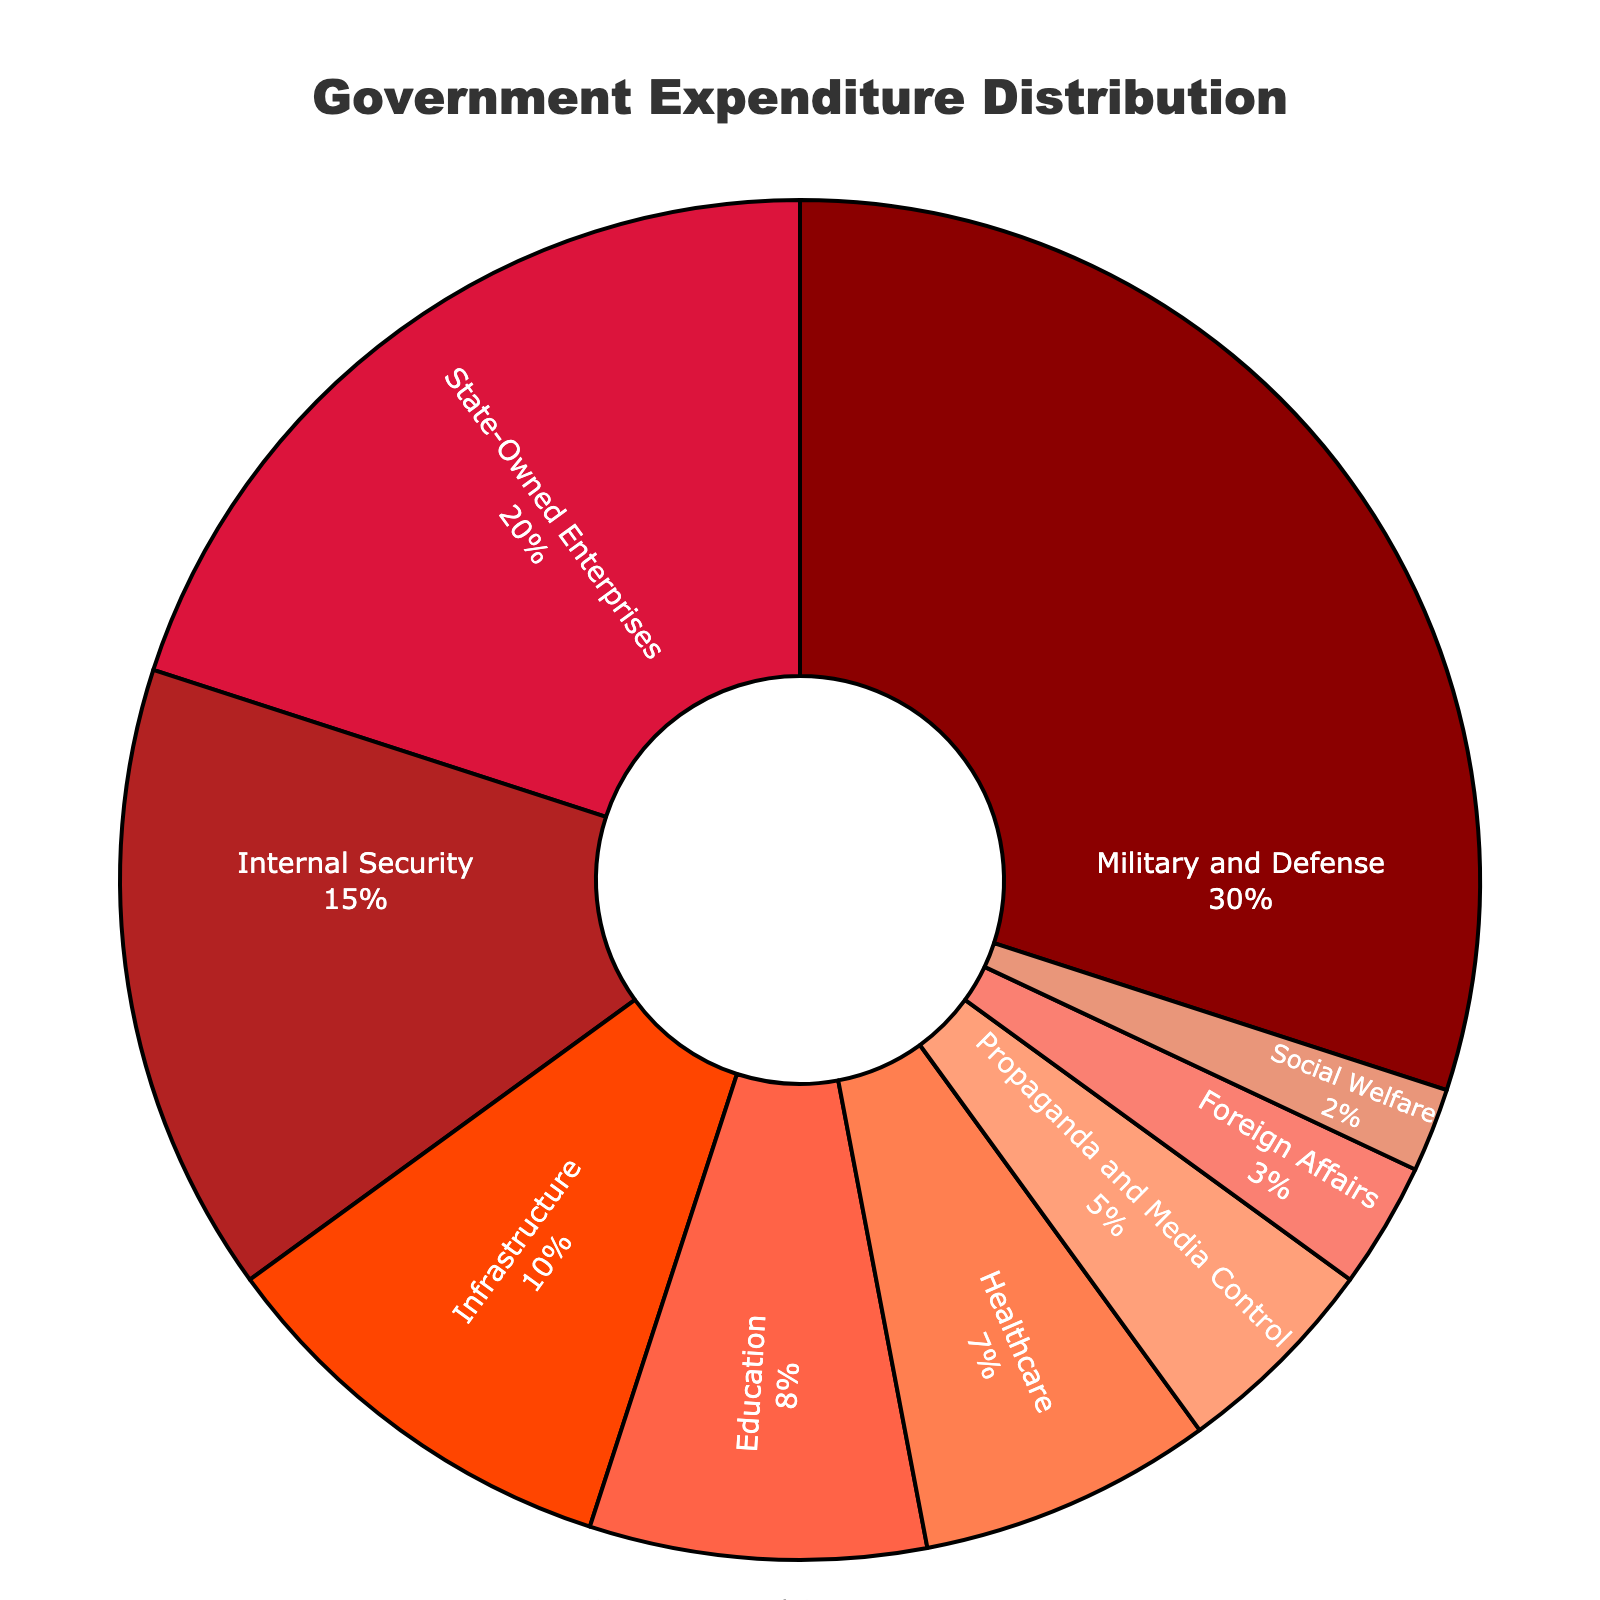What percentage of government expenditure is allocated to Military and Defense? According to the figure, the section labeled "Military and Defense" represents 30% of the government expenditure.
Answer: 30% What is the total percentage of government expenditure for Internal Security and Healthcare combined? The percentage for Internal Security is 15% and for Healthcare is 7%. Adding these together gives 15% + 7% = 22%.
Answer: 22% Which sector receives the smallest portion of government expenditure and what is that percentage? The figure shows that Social Welfare receives the smallest portion with 2%.
Answer: Social Welfare, 2% What sector is allocated twice the percentage of Foreign Affairs? Foreign Affairs is allocated 3%. Twice of 3% is 6%, which matches no exact sector. The closest higher sectors are Education (8%) and State-Owned Enterprises (20%).
Answer: None exactly; closest higher ones are Education (8%) and State-Owned Enterprises (20%) Are Military and Defense combined with Propaganda and Media Control higher or lower than the State-Owned Enterprises? Military and Defense accounts for 30%, and Propaganda and Media Control accounts for 5%, totaling 35%. State-Owned Enterprises account for 20%. Since 35% is greater than 20%, the combined amount is higher.
Answer: Higher How does the expenditure on Infrastructure compare to that on Education? Expenditure on Infrastructure is 10%, and on Education, it's 8%. Infrastructure expenditure is higher by 2%.
Answer: Infrastructure is higher What is the combined total percentage expenditure of sectors receiving less than 5% each? Only Foreign Affairs (3%) and Social Welfare (2%) are under 5%. Their combined total is 3% + 2% = 5%.
Answer: 5% Which sectors have expenditure percentages in single digits? According to the figure, the sectors with single-digit percentages are Education (8%), Healthcare (7%), Propaganda and Media Control (5%), Foreign Affairs (3%), Social Welfare (2%).
Answer: Education, Healthcare, Propaganda and Media Control, Foreign Affairs, Social Welfare What percentage of the government's expenditure goes to sectors related to defense (Military and Defense, Internal Security)? Military and Defense is 30% and Internal Security is 15%. Summed, this is 30% + 15% = 45%.
Answer: 45% 